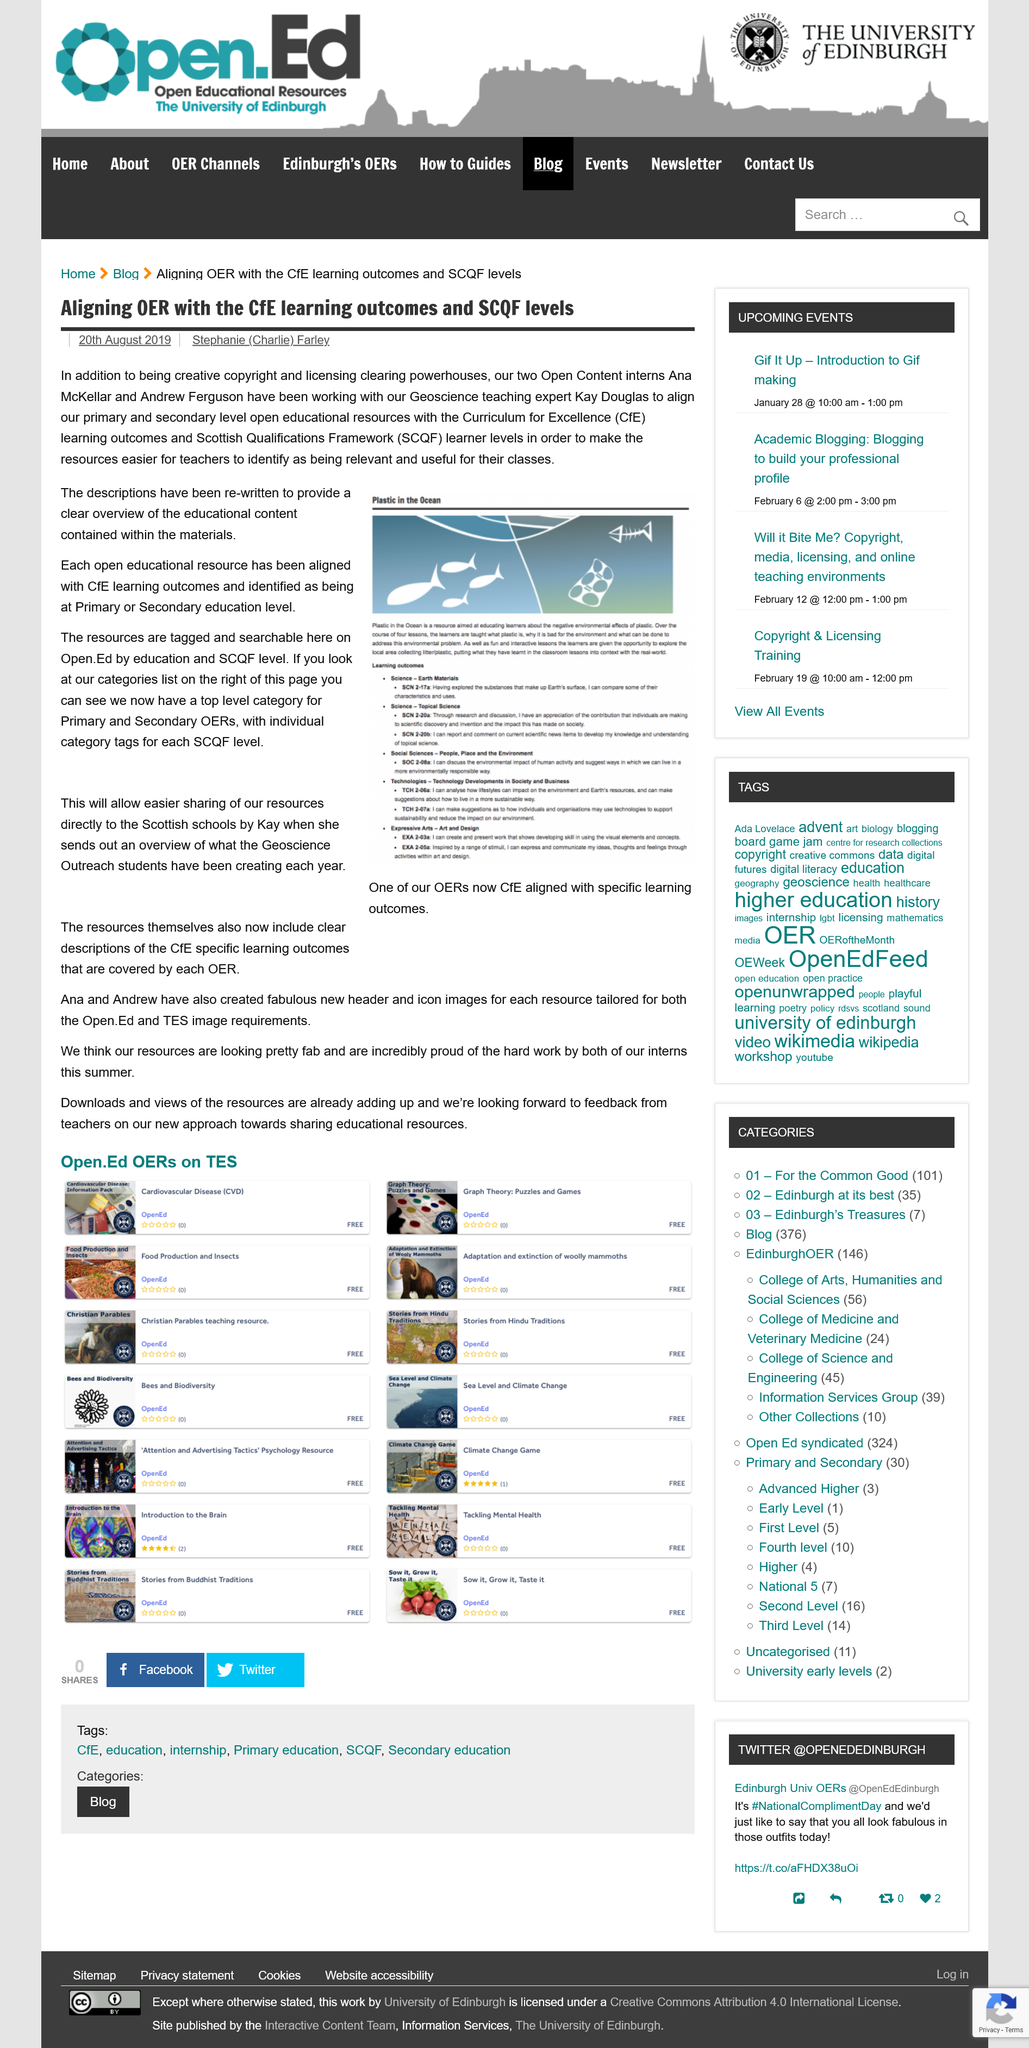Draw attention to some important aspects in this diagram. The resources provided include clear and descriptive information about the CfE specific learning outcomes. In the picture, plastic waste can be clearly seen floating in the ocean. The article was written by Stephanie Farley. The creation of the new header icon was accomplished by Ana and Andrew. The article was published on August 20th, 2019. 